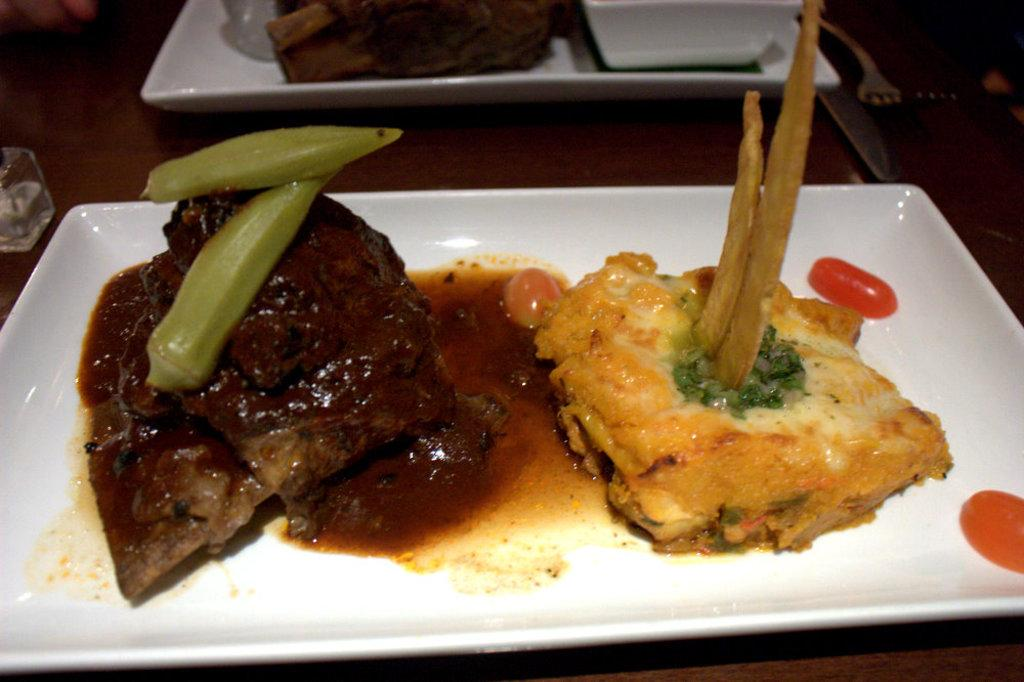What is on the plates in the image? There is food in the plates in the image. What utensils are present beside the plates? There is a fork and a knife beside the plates. What type of music is being played in the background of the image? There is no indication of music being played in the image; it only shows plates with food and utensils. 